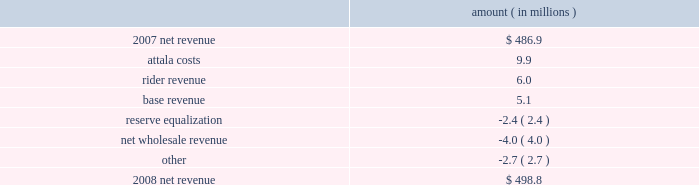Entergy mississippi , inc .
Management's financial discussion and analysis results of operations net income 2008 compared to 2007 net income decreased $ 12.4 million primarily due to higher other operation and maintenance expenses , lower other income , and higher depreciation and amortization expenses , partially offset by higher net revenue .
2007 compared to 2006 net income increased $ 19.8 million primarily due to higher net revenue , lower other operation and maintenance expenses , higher other income , and lower interest expense , partially offset by higher depreciation and amortization expenses .
Net revenue 2008 compared to 2007 net revenue consists of operating revenues net of : 1 ) fuel , fuel-related expenses , and gas purchased for resale , 2 ) purchased power expenses , and 3 ) other regulatory charges .
Following is an analysis of the change in net revenue comparing 2008 to 2007 .
Amount ( in millions ) .
The attala costs variance is primarily due to an increase in the attala power plant costs that are recovered through the power management rider .
The net income effect of this recovery in limited to a portion representing an allowed return on equity with the remainder offset by attala power plant costs in other operation and maintenance expenses , depreciation expenses , and taxes other than income taxes .
The recovery of attala power plant costs is discussed further in "liquidity and capital resources - uses of capital" below .
The rider revenue variance is the result of a storm damage rider that became effective in october 2007 .
The establishment of this rider results in an increase in rider revenue and a corresponding increase in other operation and maintenance expense for the storm reserve with no effect on net income .
The base revenue variance is primarily due to a formula rate plan increase effective july 2007 .
The formula rate plan filing is discussed further in "state and local rate regulation" below .
The reserve equalization variance is primarily due to changes in the entergy system generation mix compared to the same period in 2007. .
What percent of the change in net revenue was due to rider revenue? 
Computations: (6 / (498.8 - 486.9))
Answer: 0.5042. 